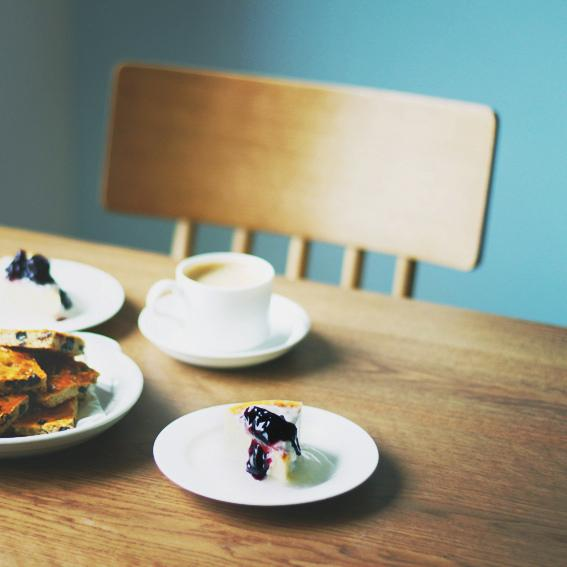What meal is being served?

Choices:
A) dinner
B) breakfast
C) afternoon tea
D) lunch afternoon tea 